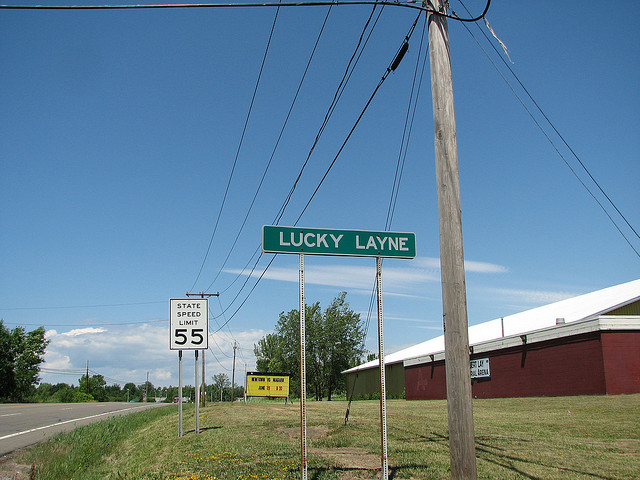Read and extract the text from this image. LUCKY LAYNE 55 LIMIT STATE SPEED 